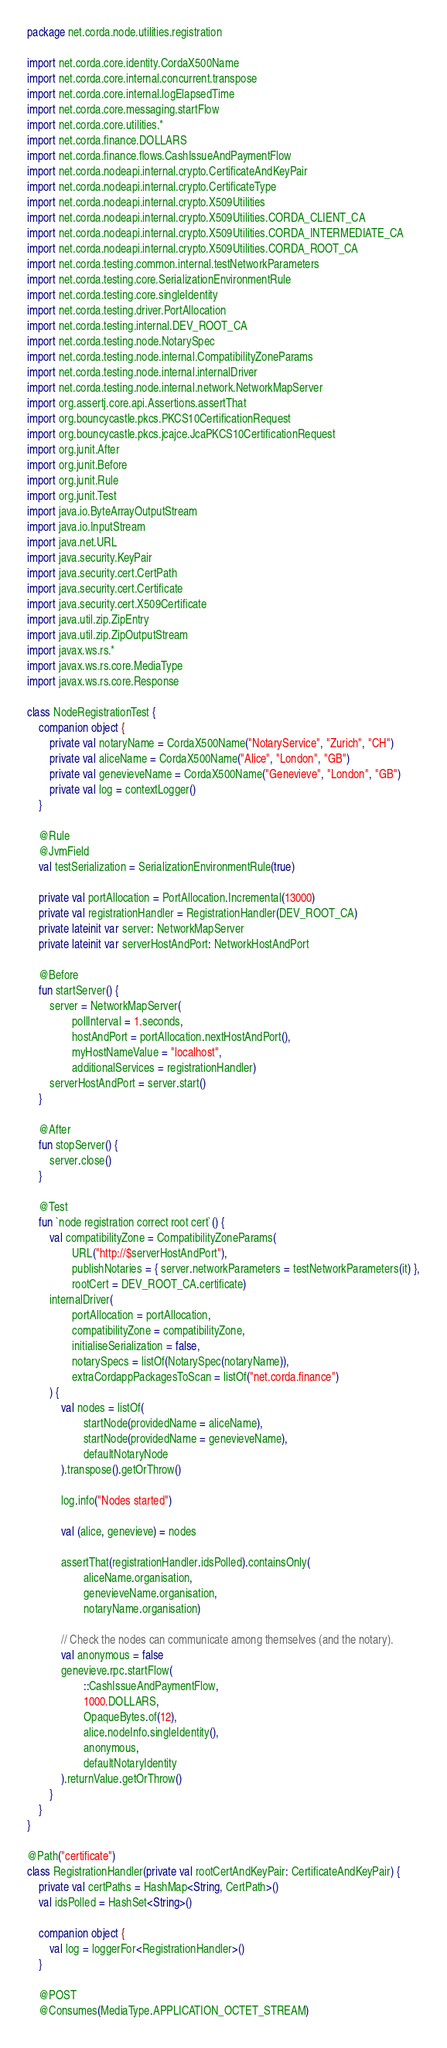<code> <loc_0><loc_0><loc_500><loc_500><_Kotlin_>package net.corda.node.utilities.registration

import net.corda.core.identity.CordaX500Name
import net.corda.core.internal.concurrent.transpose
import net.corda.core.internal.logElapsedTime
import net.corda.core.messaging.startFlow
import net.corda.core.utilities.*
import net.corda.finance.DOLLARS
import net.corda.finance.flows.CashIssueAndPaymentFlow
import net.corda.nodeapi.internal.crypto.CertificateAndKeyPair
import net.corda.nodeapi.internal.crypto.CertificateType
import net.corda.nodeapi.internal.crypto.X509Utilities
import net.corda.nodeapi.internal.crypto.X509Utilities.CORDA_CLIENT_CA
import net.corda.nodeapi.internal.crypto.X509Utilities.CORDA_INTERMEDIATE_CA
import net.corda.nodeapi.internal.crypto.X509Utilities.CORDA_ROOT_CA
import net.corda.testing.common.internal.testNetworkParameters
import net.corda.testing.core.SerializationEnvironmentRule
import net.corda.testing.core.singleIdentity
import net.corda.testing.driver.PortAllocation
import net.corda.testing.internal.DEV_ROOT_CA
import net.corda.testing.node.NotarySpec
import net.corda.testing.node.internal.CompatibilityZoneParams
import net.corda.testing.node.internal.internalDriver
import net.corda.testing.node.internal.network.NetworkMapServer
import org.assertj.core.api.Assertions.assertThat
import org.bouncycastle.pkcs.PKCS10CertificationRequest
import org.bouncycastle.pkcs.jcajce.JcaPKCS10CertificationRequest
import org.junit.After
import org.junit.Before
import org.junit.Rule
import org.junit.Test
import java.io.ByteArrayOutputStream
import java.io.InputStream
import java.net.URL
import java.security.KeyPair
import java.security.cert.CertPath
import java.security.cert.Certificate
import java.security.cert.X509Certificate
import java.util.zip.ZipEntry
import java.util.zip.ZipOutputStream
import javax.ws.rs.*
import javax.ws.rs.core.MediaType
import javax.ws.rs.core.Response

class NodeRegistrationTest {
    companion object {
        private val notaryName = CordaX500Name("NotaryService", "Zurich", "CH")
        private val aliceName = CordaX500Name("Alice", "London", "GB")
        private val genevieveName = CordaX500Name("Genevieve", "London", "GB")
        private val log = contextLogger()
    }

    @Rule
    @JvmField
    val testSerialization = SerializationEnvironmentRule(true)

    private val portAllocation = PortAllocation.Incremental(13000)
    private val registrationHandler = RegistrationHandler(DEV_ROOT_CA)
    private lateinit var server: NetworkMapServer
    private lateinit var serverHostAndPort: NetworkHostAndPort

    @Before
    fun startServer() {
        server = NetworkMapServer(
                pollInterval = 1.seconds,
                hostAndPort = portAllocation.nextHostAndPort(),
                myHostNameValue = "localhost",
                additionalServices = registrationHandler)
        serverHostAndPort = server.start()
    }

    @After
    fun stopServer() {
        server.close()
    }

    @Test
    fun `node registration correct root cert`() {
        val compatibilityZone = CompatibilityZoneParams(
                URL("http://$serverHostAndPort"),
                publishNotaries = { server.networkParameters = testNetworkParameters(it) },
                rootCert = DEV_ROOT_CA.certificate)
        internalDriver(
                portAllocation = portAllocation,
                compatibilityZone = compatibilityZone,
                initialiseSerialization = false,
                notarySpecs = listOf(NotarySpec(notaryName)),
                extraCordappPackagesToScan = listOf("net.corda.finance")
        ) {
            val nodes = listOf(
                    startNode(providedName = aliceName),
                    startNode(providedName = genevieveName),
                    defaultNotaryNode
            ).transpose().getOrThrow()

            log.info("Nodes started")

            val (alice, genevieve) = nodes

            assertThat(registrationHandler.idsPolled).containsOnly(
                    aliceName.organisation,
                    genevieveName.organisation,
                    notaryName.organisation)

            // Check the nodes can communicate among themselves (and the notary).
            val anonymous = false
            genevieve.rpc.startFlow(
                    ::CashIssueAndPaymentFlow,
                    1000.DOLLARS,
                    OpaqueBytes.of(12),
                    alice.nodeInfo.singleIdentity(),
                    anonymous,
                    defaultNotaryIdentity
            ).returnValue.getOrThrow()
        }
    }
}

@Path("certificate")
class RegistrationHandler(private val rootCertAndKeyPair: CertificateAndKeyPair) {
    private val certPaths = HashMap<String, CertPath>()
    val idsPolled = HashSet<String>()

    companion object {
        val log = loggerFor<RegistrationHandler>()
    }

    @POST
    @Consumes(MediaType.APPLICATION_OCTET_STREAM)</code> 